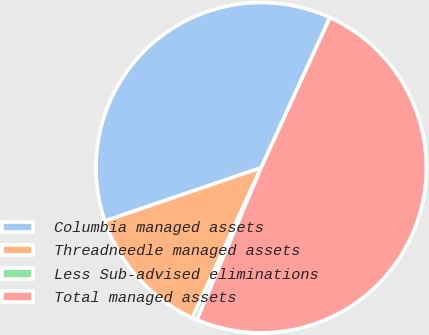Convert chart to OTSL. <chart><loc_0><loc_0><loc_500><loc_500><pie_chart><fcel>Columbia managed assets<fcel>Threadneedle managed assets<fcel>Less Sub-advised eliminations<fcel>Total managed assets<nl><fcel>37.08%<fcel>12.92%<fcel>0.48%<fcel>49.52%<nl></chart> 